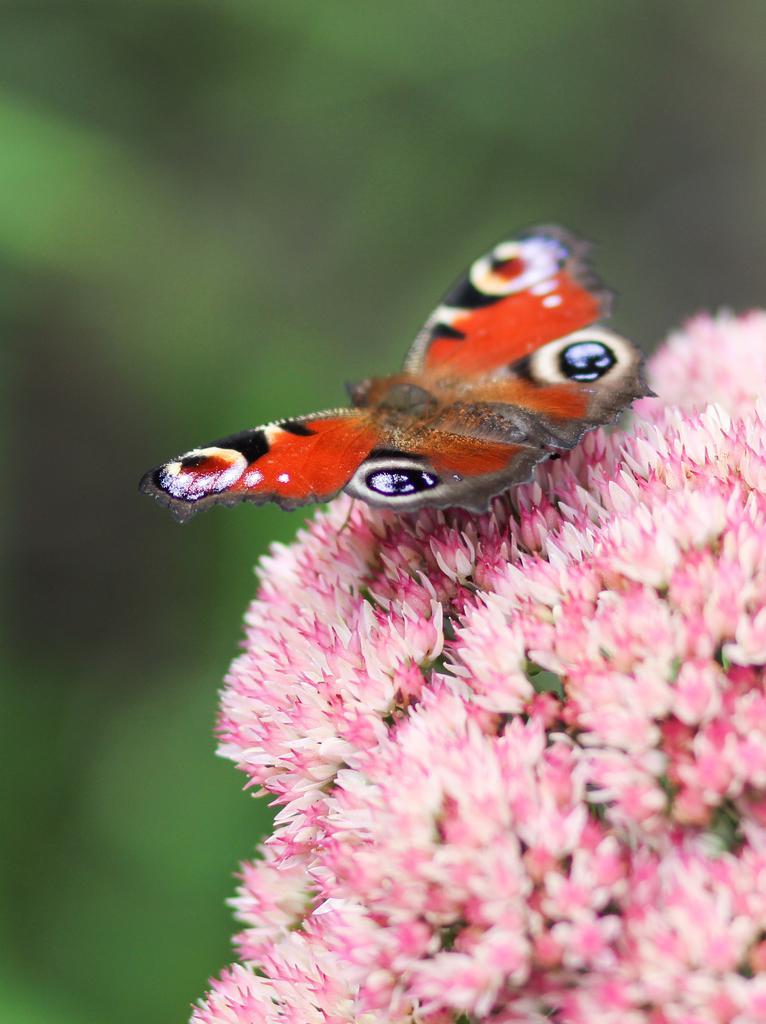Describe this image in one or two sentences. In this image I can see a butterfly which is orange, white, black and brown in color on the flowers which are pink and cream in color. I can see the blurry background which is green in color. 